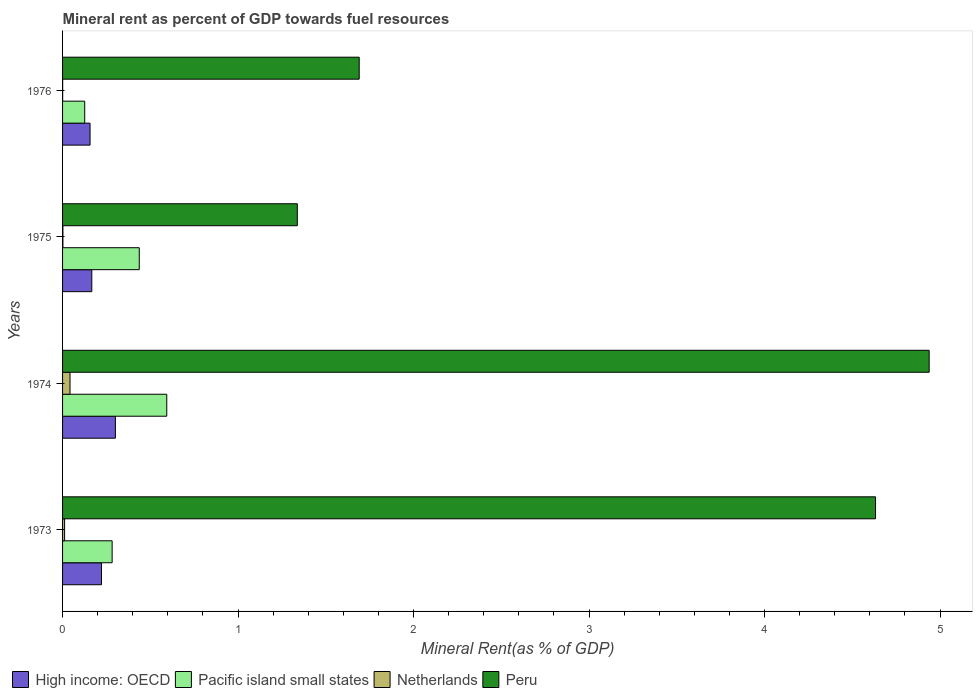How many groups of bars are there?
Offer a terse response. 4. Are the number of bars per tick equal to the number of legend labels?
Offer a terse response. Yes. Are the number of bars on each tick of the Y-axis equal?
Keep it short and to the point. Yes. How many bars are there on the 3rd tick from the top?
Make the answer very short. 4. How many bars are there on the 2nd tick from the bottom?
Ensure brevity in your answer.  4. What is the label of the 2nd group of bars from the top?
Your answer should be very brief. 1975. What is the mineral rent in Peru in 1976?
Provide a succinct answer. 1.69. Across all years, what is the maximum mineral rent in Peru?
Give a very brief answer. 4.94. Across all years, what is the minimum mineral rent in Peru?
Your answer should be very brief. 1.34. In which year was the mineral rent in High income: OECD maximum?
Provide a succinct answer. 1974. In which year was the mineral rent in Pacific island small states minimum?
Ensure brevity in your answer.  1976. What is the total mineral rent in Pacific island small states in the graph?
Offer a very short reply. 1.44. What is the difference between the mineral rent in Pacific island small states in 1974 and that in 1975?
Ensure brevity in your answer.  0.16. What is the difference between the mineral rent in Pacific island small states in 1975 and the mineral rent in High income: OECD in 1976?
Keep it short and to the point. 0.28. What is the average mineral rent in Netherlands per year?
Offer a terse response. 0.01. In the year 1973, what is the difference between the mineral rent in Netherlands and mineral rent in Peru?
Your answer should be compact. -4.62. In how many years, is the mineral rent in Peru greater than 1.8 %?
Provide a succinct answer. 2. What is the ratio of the mineral rent in Netherlands in 1975 to that in 1976?
Offer a terse response. 3.61. Is the difference between the mineral rent in Netherlands in 1974 and 1975 greater than the difference between the mineral rent in Peru in 1974 and 1975?
Ensure brevity in your answer.  No. What is the difference between the highest and the second highest mineral rent in Peru?
Offer a very short reply. 0.31. What is the difference between the highest and the lowest mineral rent in Peru?
Ensure brevity in your answer.  3.6. In how many years, is the mineral rent in Pacific island small states greater than the average mineral rent in Pacific island small states taken over all years?
Provide a short and direct response. 2. Is the sum of the mineral rent in Pacific island small states in 1973 and 1974 greater than the maximum mineral rent in Netherlands across all years?
Provide a succinct answer. Yes. What does the 1st bar from the bottom in 1974 represents?
Provide a short and direct response. High income: OECD. How many years are there in the graph?
Provide a short and direct response. 4. Are the values on the major ticks of X-axis written in scientific E-notation?
Offer a very short reply. No. Where does the legend appear in the graph?
Your answer should be very brief. Bottom left. How many legend labels are there?
Keep it short and to the point. 4. How are the legend labels stacked?
Your answer should be compact. Horizontal. What is the title of the graph?
Keep it short and to the point. Mineral rent as percent of GDP towards fuel resources. Does "Ecuador" appear as one of the legend labels in the graph?
Offer a terse response. No. What is the label or title of the X-axis?
Your response must be concise. Mineral Rent(as % of GDP). What is the Mineral Rent(as % of GDP) of High income: OECD in 1973?
Ensure brevity in your answer.  0.22. What is the Mineral Rent(as % of GDP) in Pacific island small states in 1973?
Offer a terse response. 0.28. What is the Mineral Rent(as % of GDP) in Netherlands in 1973?
Ensure brevity in your answer.  0.01. What is the Mineral Rent(as % of GDP) of Peru in 1973?
Your response must be concise. 4.63. What is the Mineral Rent(as % of GDP) in High income: OECD in 1974?
Make the answer very short. 0.3. What is the Mineral Rent(as % of GDP) of Pacific island small states in 1974?
Give a very brief answer. 0.59. What is the Mineral Rent(as % of GDP) in Netherlands in 1974?
Keep it short and to the point. 0.04. What is the Mineral Rent(as % of GDP) in Peru in 1974?
Offer a terse response. 4.94. What is the Mineral Rent(as % of GDP) of High income: OECD in 1975?
Give a very brief answer. 0.17. What is the Mineral Rent(as % of GDP) in Pacific island small states in 1975?
Offer a very short reply. 0.44. What is the Mineral Rent(as % of GDP) of Netherlands in 1975?
Offer a very short reply. 0. What is the Mineral Rent(as % of GDP) of Peru in 1975?
Offer a very short reply. 1.34. What is the Mineral Rent(as % of GDP) of High income: OECD in 1976?
Give a very brief answer. 0.16. What is the Mineral Rent(as % of GDP) in Pacific island small states in 1976?
Provide a short and direct response. 0.13. What is the Mineral Rent(as % of GDP) of Netherlands in 1976?
Give a very brief answer. 0. What is the Mineral Rent(as % of GDP) of Peru in 1976?
Provide a succinct answer. 1.69. Across all years, what is the maximum Mineral Rent(as % of GDP) of High income: OECD?
Your answer should be very brief. 0.3. Across all years, what is the maximum Mineral Rent(as % of GDP) of Pacific island small states?
Your response must be concise. 0.59. Across all years, what is the maximum Mineral Rent(as % of GDP) in Netherlands?
Keep it short and to the point. 0.04. Across all years, what is the maximum Mineral Rent(as % of GDP) in Peru?
Offer a very short reply. 4.94. Across all years, what is the minimum Mineral Rent(as % of GDP) in High income: OECD?
Give a very brief answer. 0.16. Across all years, what is the minimum Mineral Rent(as % of GDP) of Pacific island small states?
Offer a terse response. 0.13. Across all years, what is the minimum Mineral Rent(as % of GDP) in Netherlands?
Your response must be concise. 0. Across all years, what is the minimum Mineral Rent(as % of GDP) in Peru?
Your answer should be very brief. 1.34. What is the total Mineral Rent(as % of GDP) in High income: OECD in the graph?
Provide a short and direct response. 0.85. What is the total Mineral Rent(as % of GDP) in Pacific island small states in the graph?
Keep it short and to the point. 1.44. What is the total Mineral Rent(as % of GDP) of Netherlands in the graph?
Make the answer very short. 0.06. What is the total Mineral Rent(as % of GDP) of Peru in the graph?
Your response must be concise. 12.6. What is the difference between the Mineral Rent(as % of GDP) in High income: OECD in 1973 and that in 1974?
Your response must be concise. -0.08. What is the difference between the Mineral Rent(as % of GDP) in Pacific island small states in 1973 and that in 1974?
Offer a very short reply. -0.31. What is the difference between the Mineral Rent(as % of GDP) of Netherlands in 1973 and that in 1974?
Keep it short and to the point. -0.03. What is the difference between the Mineral Rent(as % of GDP) of Peru in 1973 and that in 1974?
Keep it short and to the point. -0.31. What is the difference between the Mineral Rent(as % of GDP) in High income: OECD in 1973 and that in 1975?
Keep it short and to the point. 0.06. What is the difference between the Mineral Rent(as % of GDP) of Pacific island small states in 1973 and that in 1975?
Provide a succinct answer. -0.15. What is the difference between the Mineral Rent(as % of GDP) of Netherlands in 1973 and that in 1975?
Offer a terse response. 0.01. What is the difference between the Mineral Rent(as % of GDP) in Peru in 1973 and that in 1975?
Ensure brevity in your answer.  3.29. What is the difference between the Mineral Rent(as % of GDP) of High income: OECD in 1973 and that in 1976?
Offer a terse response. 0.07. What is the difference between the Mineral Rent(as % of GDP) in Pacific island small states in 1973 and that in 1976?
Make the answer very short. 0.16. What is the difference between the Mineral Rent(as % of GDP) of Netherlands in 1973 and that in 1976?
Provide a succinct answer. 0.01. What is the difference between the Mineral Rent(as % of GDP) in Peru in 1973 and that in 1976?
Offer a very short reply. 2.94. What is the difference between the Mineral Rent(as % of GDP) in High income: OECD in 1974 and that in 1975?
Your response must be concise. 0.13. What is the difference between the Mineral Rent(as % of GDP) of Pacific island small states in 1974 and that in 1975?
Keep it short and to the point. 0.16. What is the difference between the Mineral Rent(as % of GDP) of Netherlands in 1974 and that in 1975?
Provide a succinct answer. 0.04. What is the difference between the Mineral Rent(as % of GDP) of Peru in 1974 and that in 1975?
Your answer should be very brief. 3.6. What is the difference between the Mineral Rent(as % of GDP) in High income: OECD in 1974 and that in 1976?
Offer a terse response. 0.14. What is the difference between the Mineral Rent(as % of GDP) of Pacific island small states in 1974 and that in 1976?
Provide a succinct answer. 0.47. What is the difference between the Mineral Rent(as % of GDP) of Netherlands in 1974 and that in 1976?
Offer a terse response. 0.04. What is the difference between the Mineral Rent(as % of GDP) in Peru in 1974 and that in 1976?
Offer a terse response. 3.25. What is the difference between the Mineral Rent(as % of GDP) in High income: OECD in 1975 and that in 1976?
Make the answer very short. 0.01. What is the difference between the Mineral Rent(as % of GDP) in Pacific island small states in 1975 and that in 1976?
Make the answer very short. 0.31. What is the difference between the Mineral Rent(as % of GDP) of Netherlands in 1975 and that in 1976?
Your response must be concise. 0. What is the difference between the Mineral Rent(as % of GDP) in Peru in 1975 and that in 1976?
Give a very brief answer. -0.35. What is the difference between the Mineral Rent(as % of GDP) of High income: OECD in 1973 and the Mineral Rent(as % of GDP) of Pacific island small states in 1974?
Your response must be concise. -0.37. What is the difference between the Mineral Rent(as % of GDP) of High income: OECD in 1973 and the Mineral Rent(as % of GDP) of Netherlands in 1974?
Your answer should be compact. 0.18. What is the difference between the Mineral Rent(as % of GDP) of High income: OECD in 1973 and the Mineral Rent(as % of GDP) of Peru in 1974?
Your answer should be compact. -4.72. What is the difference between the Mineral Rent(as % of GDP) of Pacific island small states in 1973 and the Mineral Rent(as % of GDP) of Netherlands in 1974?
Ensure brevity in your answer.  0.24. What is the difference between the Mineral Rent(as % of GDP) in Pacific island small states in 1973 and the Mineral Rent(as % of GDP) in Peru in 1974?
Your response must be concise. -4.66. What is the difference between the Mineral Rent(as % of GDP) in Netherlands in 1973 and the Mineral Rent(as % of GDP) in Peru in 1974?
Provide a short and direct response. -4.93. What is the difference between the Mineral Rent(as % of GDP) of High income: OECD in 1973 and the Mineral Rent(as % of GDP) of Pacific island small states in 1975?
Ensure brevity in your answer.  -0.22. What is the difference between the Mineral Rent(as % of GDP) of High income: OECD in 1973 and the Mineral Rent(as % of GDP) of Netherlands in 1975?
Ensure brevity in your answer.  0.22. What is the difference between the Mineral Rent(as % of GDP) in High income: OECD in 1973 and the Mineral Rent(as % of GDP) in Peru in 1975?
Your response must be concise. -1.12. What is the difference between the Mineral Rent(as % of GDP) in Pacific island small states in 1973 and the Mineral Rent(as % of GDP) in Netherlands in 1975?
Keep it short and to the point. 0.28. What is the difference between the Mineral Rent(as % of GDP) of Pacific island small states in 1973 and the Mineral Rent(as % of GDP) of Peru in 1975?
Give a very brief answer. -1.06. What is the difference between the Mineral Rent(as % of GDP) of Netherlands in 1973 and the Mineral Rent(as % of GDP) of Peru in 1975?
Offer a very short reply. -1.33. What is the difference between the Mineral Rent(as % of GDP) of High income: OECD in 1973 and the Mineral Rent(as % of GDP) of Pacific island small states in 1976?
Your answer should be very brief. 0.1. What is the difference between the Mineral Rent(as % of GDP) in High income: OECD in 1973 and the Mineral Rent(as % of GDP) in Netherlands in 1976?
Give a very brief answer. 0.22. What is the difference between the Mineral Rent(as % of GDP) of High income: OECD in 1973 and the Mineral Rent(as % of GDP) of Peru in 1976?
Your answer should be compact. -1.47. What is the difference between the Mineral Rent(as % of GDP) of Pacific island small states in 1973 and the Mineral Rent(as % of GDP) of Netherlands in 1976?
Keep it short and to the point. 0.28. What is the difference between the Mineral Rent(as % of GDP) of Pacific island small states in 1973 and the Mineral Rent(as % of GDP) of Peru in 1976?
Ensure brevity in your answer.  -1.41. What is the difference between the Mineral Rent(as % of GDP) in Netherlands in 1973 and the Mineral Rent(as % of GDP) in Peru in 1976?
Ensure brevity in your answer.  -1.68. What is the difference between the Mineral Rent(as % of GDP) of High income: OECD in 1974 and the Mineral Rent(as % of GDP) of Pacific island small states in 1975?
Give a very brief answer. -0.14. What is the difference between the Mineral Rent(as % of GDP) of High income: OECD in 1974 and the Mineral Rent(as % of GDP) of Netherlands in 1975?
Offer a terse response. 0.3. What is the difference between the Mineral Rent(as % of GDP) in High income: OECD in 1974 and the Mineral Rent(as % of GDP) in Peru in 1975?
Make the answer very short. -1.04. What is the difference between the Mineral Rent(as % of GDP) in Pacific island small states in 1974 and the Mineral Rent(as % of GDP) in Netherlands in 1975?
Keep it short and to the point. 0.59. What is the difference between the Mineral Rent(as % of GDP) of Pacific island small states in 1974 and the Mineral Rent(as % of GDP) of Peru in 1975?
Ensure brevity in your answer.  -0.74. What is the difference between the Mineral Rent(as % of GDP) in Netherlands in 1974 and the Mineral Rent(as % of GDP) in Peru in 1975?
Give a very brief answer. -1.3. What is the difference between the Mineral Rent(as % of GDP) in High income: OECD in 1974 and the Mineral Rent(as % of GDP) in Pacific island small states in 1976?
Your response must be concise. 0.17. What is the difference between the Mineral Rent(as % of GDP) in High income: OECD in 1974 and the Mineral Rent(as % of GDP) in Netherlands in 1976?
Your response must be concise. 0.3. What is the difference between the Mineral Rent(as % of GDP) of High income: OECD in 1974 and the Mineral Rent(as % of GDP) of Peru in 1976?
Keep it short and to the point. -1.39. What is the difference between the Mineral Rent(as % of GDP) of Pacific island small states in 1974 and the Mineral Rent(as % of GDP) of Netherlands in 1976?
Provide a short and direct response. 0.59. What is the difference between the Mineral Rent(as % of GDP) in Pacific island small states in 1974 and the Mineral Rent(as % of GDP) in Peru in 1976?
Keep it short and to the point. -1.1. What is the difference between the Mineral Rent(as % of GDP) of Netherlands in 1974 and the Mineral Rent(as % of GDP) of Peru in 1976?
Offer a terse response. -1.65. What is the difference between the Mineral Rent(as % of GDP) in High income: OECD in 1975 and the Mineral Rent(as % of GDP) in Pacific island small states in 1976?
Your response must be concise. 0.04. What is the difference between the Mineral Rent(as % of GDP) in High income: OECD in 1975 and the Mineral Rent(as % of GDP) in Netherlands in 1976?
Offer a terse response. 0.17. What is the difference between the Mineral Rent(as % of GDP) of High income: OECD in 1975 and the Mineral Rent(as % of GDP) of Peru in 1976?
Make the answer very short. -1.52. What is the difference between the Mineral Rent(as % of GDP) in Pacific island small states in 1975 and the Mineral Rent(as % of GDP) in Netherlands in 1976?
Make the answer very short. 0.44. What is the difference between the Mineral Rent(as % of GDP) of Pacific island small states in 1975 and the Mineral Rent(as % of GDP) of Peru in 1976?
Offer a terse response. -1.25. What is the difference between the Mineral Rent(as % of GDP) of Netherlands in 1975 and the Mineral Rent(as % of GDP) of Peru in 1976?
Keep it short and to the point. -1.69. What is the average Mineral Rent(as % of GDP) of High income: OECD per year?
Your response must be concise. 0.21. What is the average Mineral Rent(as % of GDP) in Pacific island small states per year?
Your answer should be very brief. 0.36. What is the average Mineral Rent(as % of GDP) in Netherlands per year?
Give a very brief answer. 0.01. What is the average Mineral Rent(as % of GDP) of Peru per year?
Give a very brief answer. 3.15. In the year 1973, what is the difference between the Mineral Rent(as % of GDP) in High income: OECD and Mineral Rent(as % of GDP) in Pacific island small states?
Ensure brevity in your answer.  -0.06. In the year 1973, what is the difference between the Mineral Rent(as % of GDP) of High income: OECD and Mineral Rent(as % of GDP) of Netherlands?
Ensure brevity in your answer.  0.21. In the year 1973, what is the difference between the Mineral Rent(as % of GDP) of High income: OECD and Mineral Rent(as % of GDP) of Peru?
Make the answer very short. -4.41. In the year 1973, what is the difference between the Mineral Rent(as % of GDP) of Pacific island small states and Mineral Rent(as % of GDP) of Netherlands?
Make the answer very short. 0.27. In the year 1973, what is the difference between the Mineral Rent(as % of GDP) in Pacific island small states and Mineral Rent(as % of GDP) in Peru?
Ensure brevity in your answer.  -4.35. In the year 1973, what is the difference between the Mineral Rent(as % of GDP) of Netherlands and Mineral Rent(as % of GDP) of Peru?
Offer a very short reply. -4.62. In the year 1974, what is the difference between the Mineral Rent(as % of GDP) of High income: OECD and Mineral Rent(as % of GDP) of Pacific island small states?
Your answer should be compact. -0.29. In the year 1974, what is the difference between the Mineral Rent(as % of GDP) in High income: OECD and Mineral Rent(as % of GDP) in Netherlands?
Give a very brief answer. 0.26. In the year 1974, what is the difference between the Mineral Rent(as % of GDP) in High income: OECD and Mineral Rent(as % of GDP) in Peru?
Your answer should be compact. -4.64. In the year 1974, what is the difference between the Mineral Rent(as % of GDP) in Pacific island small states and Mineral Rent(as % of GDP) in Netherlands?
Your answer should be compact. 0.55. In the year 1974, what is the difference between the Mineral Rent(as % of GDP) in Pacific island small states and Mineral Rent(as % of GDP) in Peru?
Ensure brevity in your answer.  -4.34. In the year 1974, what is the difference between the Mineral Rent(as % of GDP) in Netherlands and Mineral Rent(as % of GDP) in Peru?
Offer a terse response. -4.9. In the year 1975, what is the difference between the Mineral Rent(as % of GDP) in High income: OECD and Mineral Rent(as % of GDP) in Pacific island small states?
Your answer should be compact. -0.27. In the year 1975, what is the difference between the Mineral Rent(as % of GDP) of High income: OECD and Mineral Rent(as % of GDP) of Netherlands?
Keep it short and to the point. 0.16. In the year 1975, what is the difference between the Mineral Rent(as % of GDP) in High income: OECD and Mineral Rent(as % of GDP) in Peru?
Your answer should be compact. -1.17. In the year 1975, what is the difference between the Mineral Rent(as % of GDP) of Pacific island small states and Mineral Rent(as % of GDP) of Netherlands?
Provide a short and direct response. 0.44. In the year 1975, what is the difference between the Mineral Rent(as % of GDP) of Pacific island small states and Mineral Rent(as % of GDP) of Peru?
Your response must be concise. -0.9. In the year 1975, what is the difference between the Mineral Rent(as % of GDP) in Netherlands and Mineral Rent(as % of GDP) in Peru?
Provide a short and direct response. -1.34. In the year 1976, what is the difference between the Mineral Rent(as % of GDP) in High income: OECD and Mineral Rent(as % of GDP) in Pacific island small states?
Provide a short and direct response. 0.03. In the year 1976, what is the difference between the Mineral Rent(as % of GDP) of High income: OECD and Mineral Rent(as % of GDP) of Netherlands?
Ensure brevity in your answer.  0.16. In the year 1976, what is the difference between the Mineral Rent(as % of GDP) in High income: OECD and Mineral Rent(as % of GDP) in Peru?
Give a very brief answer. -1.53. In the year 1976, what is the difference between the Mineral Rent(as % of GDP) in Pacific island small states and Mineral Rent(as % of GDP) in Netherlands?
Offer a very short reply. 0.13. In the year 1976, what is the difference between the Mineral Rent(as % of GDP) of Pacific island small states and Mineral Rent(as % of GDP) of Peru?
Provide a succinct answer. -1.56. In the year 1976, what is the difference between the Mineral Rent(as % of GDP) of Netherlands and Mineral Rent(as % of GDP) of Peru?
Keep it short and to the point. -1.69. What is the ratio of the Mineral Rent(as % of GDP) in High income: OECD in 1973 to that in 1974?
Provide a short and direct response. 0.74. What is the ratio of the Mineral Rent(as % of GDP) of Pacific island small states in 1973 to that in 1974?
Ensure brevity in your answer.  0.48. What is the ratio of the Mineral Rent(as % of GDP) of Netherlands in 1973 to that in 1974?
Offer a very short reply. 0.27. What is the ratio of the Mineral Rent(as % of GDP) in Peru in 1973 to that in 1974?
Your response must be concise. 0.94. What is the ratio of the Mineral Rent(as % of GDP) of High income: OECD in 1973 to that in 1975?
Make the answer very short. 1.33. What is the ratio of the Mineral Rent(as % of GDP) in Pacific island small states in 1973 to that in 1975?
Offer a very short reply. 0.65. What is the ratio of the Mineral Rent(as % of GDP) in Netherlands in 1973 to that in 1975?
Ensure brevity in your answer.  5.97. What is the ratio of the Mineral Rent(as % of GDP) of Peru in 1973 to that in 1975?
Keep it short and to the point. 3.46. What is the ratio of the Mineral Rent(as % of GDP) in High income: OECD in 1973 to that in 1976?
Provide a short and direct response. 1.42. What is the ratio of the Mineral Rent(as % of GDP) of Pacific island small states in 1973 to that in 1976?
Offer a very short reply. 2.24. What is the ratio of the Mineral Rent(as % of GDP) in Netherlands in 1973 to that in 1976?
Your response must be concise. 21.57. What is the ratio of the Mineral Rent(as % of GDP) of Peru in 1973 to that in 1976?
Your answer should be very brief. 2.74. What is the ratio of the Mineral Rent(as % of GDP) in High income: OECD in 1974 to that in 1975?
Give a very brief answer. 1.81. What is the ratio of the Mineral Rent(as % of GDP) of Pacific island small states in 1974 to that in 1975?
Ensure brevity in your answer.  1.36. What is the ratio of the Mineral Rent(as % of GDP) in Netherlands in 1974 to that in 1975?
Provide a short and direct response. 22.01. What is the ratio of the Mineral Rent(as % of GDP) of Peru in 1974 to that in 1975?
Your answer should be compact. 3.69. What is the ratio of the Mineral Rent(as % of GDP) in High income: OECD in 1974 to that in 1976?
Your answer should be very brief. 1.92. What is the ratio of the Mineral Rent(as % of GDP) in Pacific island small states in 1974 to that in 1976?
Your answer should be compact. 4.7. What is the ratio of the Mineral Rent(as % of GDP) of Netherlands in 1974 to that in 1976?
Give a very brief answer. 79.49. What is the ratio of the Mineral Rent(as % of GDP) in Peru in 1974 to that in 1976?
Your response must be concise. 2.92. What is the ratio of the Mineral Rent(as % of GDP) in High income: OECD in 1975 to that in 1976?
Make the answer very short. 1.06. What is the ratio of the Mineral Rent(as % of GDP) of Pacific island small states in 1975 to that in 1976?
Your response must be concise. 3.46. What is the ratio of the Mineral Rent(as % of GDP) in Netherlands in 1975 to that in 1976?
Provide a short and direct response. 3.61. What is the ratio of the Mineral Rent(as % of GDP) in Peru in 1975 to that in 1976?
Give a very brief answer. 0.79. What is the difference between the highest and the second highest Mineral Rent(as % of GDP) of High income: OECD?
Give a very brief answer. 0.08. What is the difference between the highest and the second highest Mineral Rent(as % of GDP) of Pacific island small states?
Provide a succinct answer. 0.16. What is the difference between the highest and the second highest Mineral Rent(as % of GDP) of Netherlands?
Keep it short and to the point. 0.03. What is the difference between the highest and the second highest Mineral Rent(as % of GDP) in Peru?
Your answer should be very brief. 0.31. What is the difference between the highest and the lowest Mineral Rent(as % of GDP) in High income: OECD?
Provide a short and direct response. 0.14. What is the difference between the highest and the lowest Mineral Rent(as % of GDP) in Pacific island small states?
Give a very brief answer. 0.47. What is the difference between the highest and the lowest Mineral Rent(as % of GDP) in Netherlands?
Provide a short and direct response. 0.04. What is the difference between the highest and the lowest Mineral Rent(as % of GDP) in Peru?
Make the answer very short. 3.6. 